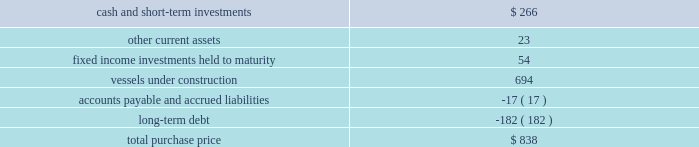Part ii , item 8 fourth quarter of 2007 : 0160 schlumberger sold certain workover rigs for $ 32 million , resulting in a pretax gain of $ 24 million ( $ 17 million after-tax ) which is classified in interest and other income , net in the consolidated statement of income .
Acquisitions acquisition of eastern echo holding plc on december 10 , 2007 , schlumberger completed the acquisition of eastern echo holding plc ( 201ceastern echo 201d ) for $ 838 million in cash .
Eastern echo was a dubai-based marine seismic company that did not have any operations at the time of acquisition , but had signed contracts for the construction of six seismic vessels .
The purchase price has been allocated to the net assets acquired based upon their estimated fair values as follows : ( stated in millions ) .
Other acquisitions schlumberger has made other acquisitions and minority interest investments , none of which were significant on an individual basis , for cash payments , net of cash acquired , of $ 514 million during 2009 , $ 345 million during 2008 , and $ 281 million during 2007 .
Pro forma results pertaining to the above acquisitions are not presented as the impact was not significant .
Drilling fluids joint venture the mi-swaco drilling fluids joint venture is owned 40% ( 40 % ) by schlumberger and 60% ( 60 % ) by smith international , inc .
Schlumberger records income relating to this venture using the equity method of accounting .
The carrying value of schlumberger 2019s investment in the joint venture on december 31 , 2009 and 2008 was $ 1.4 billion and $ 1.3 billion , respectively , and is included within investments in affiliated companies on the consolidated balance sheet .
Schlumberger 2019s equity income from this joint venture was $ 131 million in 2009 , $ 210 million in 2008 and $ 178 million in 2007 .
Schlumberger received cash distributions from the joint venture of $ 106 million in 2009 , $ 57 million in 2008 and $ 46 million in 2007 .
The joint venture agreement contains a provision under which either party to the joint venture may offer to sell its entire interest in the venture to the other party at a cash purchase price per percentage interest specified in an offer notice .
If the offer to sell is not accepted , the offering party will be obligated to purchase the entire interest of the other party at the same price per percentage interest as the prices specified in the offer notice. .
What was vessels under construction as a percentage of total purchase price? 
Computations: (694 / 838)
Answer: 0.82816. 